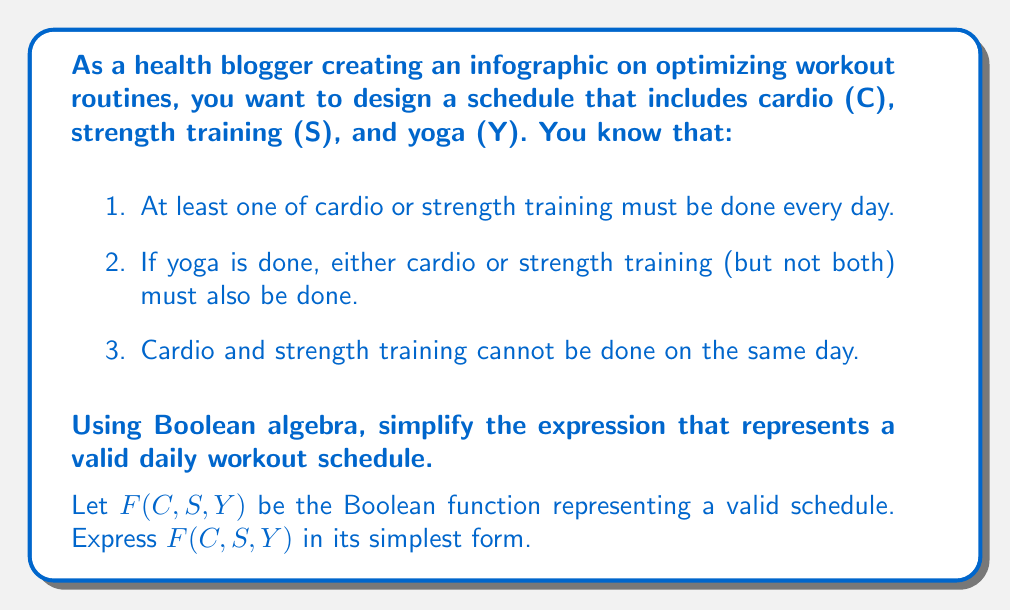Could you help me with this problem? Let's approach this step-by-step:

1) First, let's express each condition as a Boolean expression:
   
   Condition 1: $C \lor S$
   Condition 2: $Y \rightarrow (C \oplus S)$, where $\oplus$ is XOR
   Condition 3: $\lnot(C \land S)$

2) The final expression will be the AND of all these conditions:

   $F(C,S,Y) = (C \lor S) \land (Y \rightarrow (C \oplus S)) \land \lnot(C \land S)$

3) Let's simplify the second condition:
   $Y \rightarrow (C \oplus S)$ is equivalent to $\lnot Y \lor (C \oplus S)$

4) Now our expression is:

   $F(C,S,Y) = (C \lor S) \land (\lnot Y \lor (C \oplus S)) \land \lnot(C \land S)$

5) Expand the XOR in the second term:
   
   $F(C,S,Y) = (C \lor S) \land (\lnot Y \lor ((C \land \lnot S) \lor (\lnot C \land S))) \land \lnot(C \land S)$

6) Distribute the OR over the AND in the second term:

   $F(C,S,Y) = (C \lor S) \land (\lnot Y \lor (C \land \lnot S) \lor (\lnot C \land S)) \land \lnot(C \land S)$

7) The last term $\lnot(C \land S)$ is redundant because it's already implied by $(C \land \lnot S) \lor (\lnot C \land S)$, so we can remove it:

   $F(C,S,Y) = (C \lor S) \land (\lnot Y \lor (C \land \lnot S) \lor (\lnot C \land S))$

8) This is the simplest form of the Boolean function representing a valid workout schedule.
Answer: $F(C,S,Y) = (C \lor S) \land (\lnot Y \lor (C \land \lnot S) \lor (\lnot C \land S))$ 